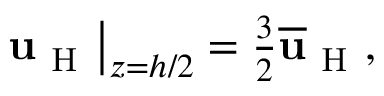<formula> <loc_0><loc_0><loc_500><loc_500>\begin{array} { r } { u _ { H } \right | _ { z = h / 2 } = \frac { 3 } { 2 } \overline { u } _ { H } , } \end{array}</formula> 